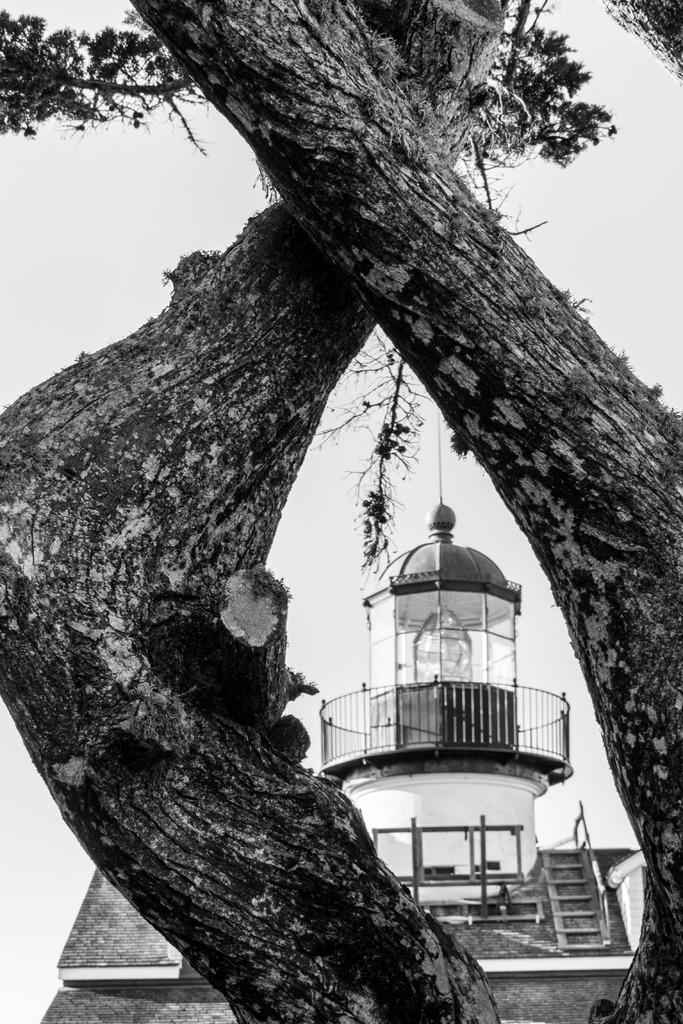Describe this image in one or two sentences. This is a black and white image. In the center of the image we can see a building, railing, stairs, rods, roof. In the background of the image we can see the trees. At the top of the image we can see the sky. 